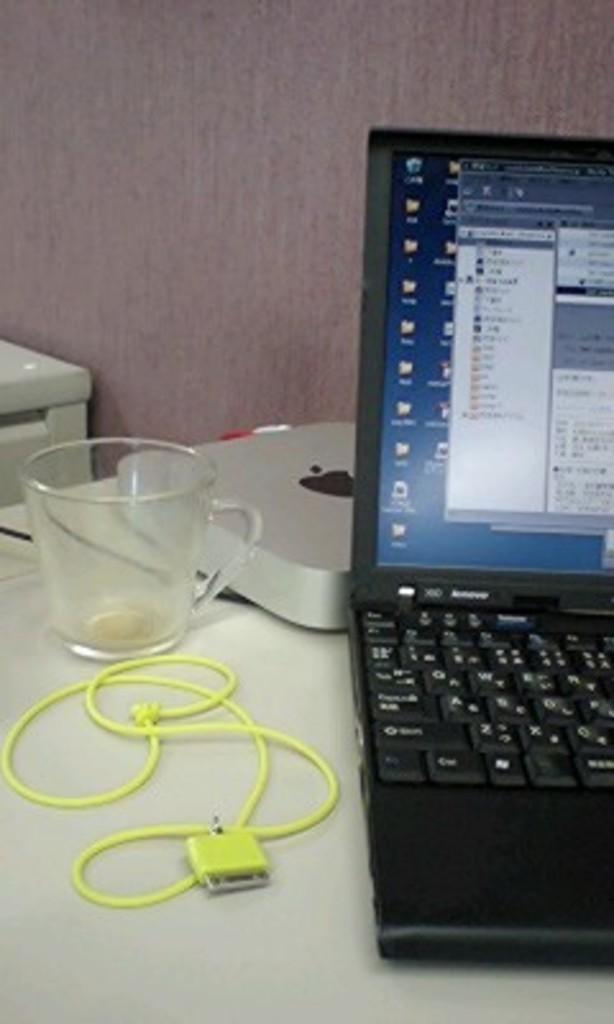How would you summarize this image in a sentence or two? In the foreground of this image, on the table, there is a cable, cup, a chrome box and a laptop. In the background, there is a wall and an object. 